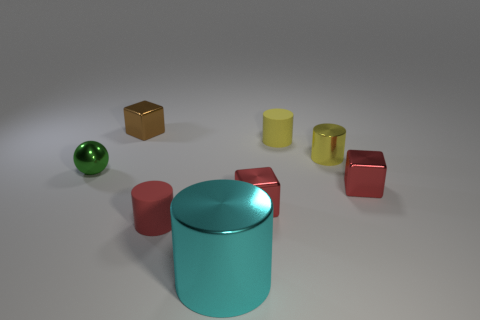There is a cyan object in front of the yellow rubber cylinder; is there a red rubber cylinder that is in front of it? Indeed, the image shows no red rubber cylinder positioned in front of the cyan object; there are only two red rubber cylinders located to the side and not directly in front of it. 